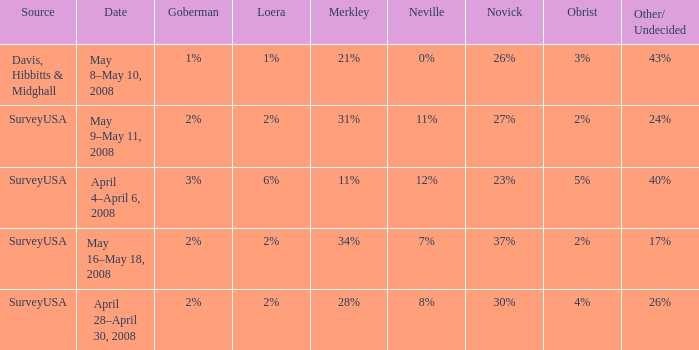Which Date has a Novick of 26%? May 8–May 10, 2008. 